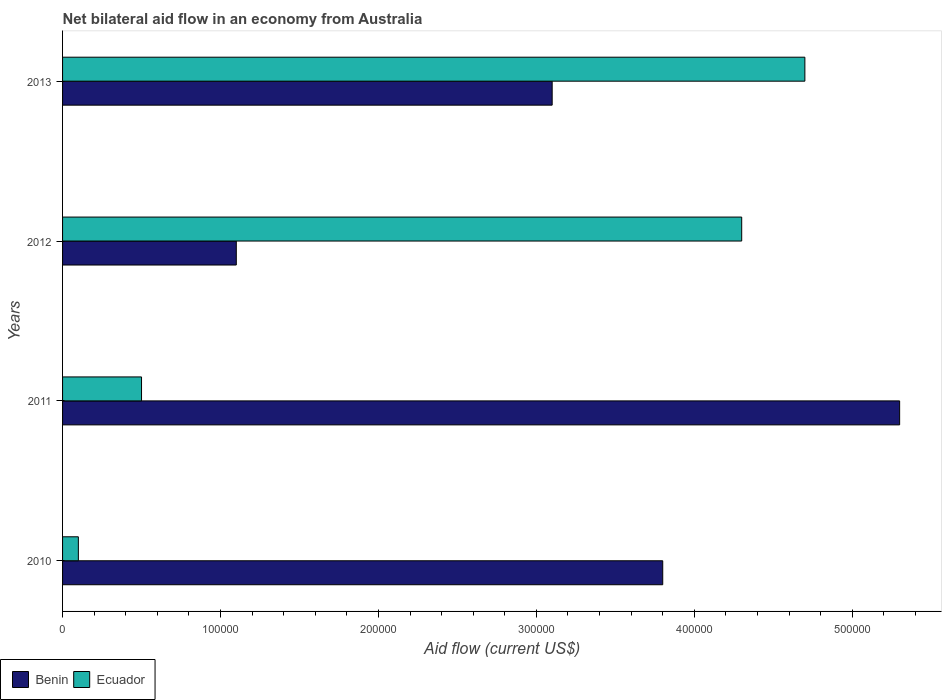How many different coloured bars are there?
Your answer should be very brief. 2. How many groups of bars are there?
Offer a terse response. 4. Are the number of bars per tick equal to the number of legend labels?
Provide a succinct answer. Yes. Are the number of bars on each tick of the Y-axis equal?
Your response must be concise. Yes. What is the label of the 1st group of bars from the top?
Offer a very short reply. 2013. In how many cases, is the number of bars for a given year not equal to the number of legend labels?
Give a very brief answer. 0. What is the net bilateral aid flow in Ecuador in 2012?
Offer a very short reply. 4.30e+05. Across all years, what is the maximum net bilateral aid flow in Benin?
Offer a terse response. 5.30e+05. Across all years, what is the minimum net bilateral aid flow in Benin?
Ensure brevity in your answer.  1.10e+05. In which year was the net bilateral aid flow in Benin maximum?
Ensure brevity in your answer.  2011. In which year was the net bilateral aid flow in Ecuador minimum?
Provide a short and direct response. 2010. What is the total net bilateral aid flow in Ecuador in the graph?
Provide a short and direct response. 9.60e+05. What is the difference between the net bilateral aid flow in Ecuador in 2010 and that in 2011?
Ensure brevity in your answer.  -4.00e+04. What is the ratio of the net bilateral aid flow in Ecuador in 2010 to that in 2012?
Provide a succinct answer. 0.02. In how many years, is the net bilateral aid flow in Benin greater than the average net bilateral aid flow in Benin taken over all years?
Provide a succinct answer. 2. What does the 2nd bar from the top in 2011 represents?
Ensure brevity in your answer.  Benin. What does the 1st bar from the bottom in 2012 represents?
Ensure brevity in your answer.  Benin. How many bars are there?
Your answer should be very brief. 8. Are all the bars in the graph horizontal?
Provide a succinct answer. Yes. What is the difference between two consecutive major ticks on the X-axis?
Offer a terse response. 1.00e+05. Where does the legend appear in the graph?
Make the answer very short. Bottom left. How many legend labels are there?
Your answer should be compact. 2. How are the legend labels stacked?
Provide a succinct answer. Horizontal. What is the title of the graph?
Your answer should be very brief. Net bilateral aid flow in an economy from Australia. Does "Spain" appear as one of the legend labels in the graph?
Ensure brevity in your answer.  No. What is the label or title of the Y-axis?
Your response must be concise. Years. What is the Aid flow (current US$) of Benin in 2010?
Keep it short and to the point. 3.80e+05. What is the Aid flow (current US$) in Ecuador in 2010?
Provide a succinct answer. 10000. What is the Aid flow (current US$) in Benin in 2011?
Ensure brevity in your answer.  5.30e+05. What is the Aid flow (current US$) of Ecuador in 2011?
Offer a very short reply. 5.00e+04. What is the Aid flow (current US$) in Benin in 2012?
Offer a very short reply. 1.10e+05. What is the Aid flow (current US$) of Ecuador in 2012?
Offer a terse response. 4.30e+05. Across all years, what is the maximum Aid flow (current US$) of Benin?
Make the answer very short. 5.30e+05. Across all years, what is the maximum Aid flow (current US$) of Ecuador?
Ensure brevity in your answer.  4.70e+05. Across all years, what is the minimum Aid flow (current US$) of Ecuador?
Your answer should be very brief. 10000. What is the total Aid flow (current US$) of Benin in the graph?
Give a very brief answer. 1.33e+06. What is the total Aid flow (current US$) in Ecuador in the graph?
Provide a succinct answer. 9.60e+05. What is the difference between the Aid flow (current US$) of Benin in 2010 and that in 2011?
Your answer should be very brief. -1.50e+05. What is the difference between the Aid flow (current US$) in Ecuador in 2010 and that in 2011?
Provide a succinct answer. -4.00e+04. What is the difference between the Aid flow (current US$) in Ecuador in 2010 and that in 2012?
Your answer should be very brief. -4.20e+05. What is the difference between the Aid flow (current US$) of Benin in 2010 and that in 2013?
Ensure brevity in your answer.  7.00e+04. What is the difference between the Aid flow (current US$) in Ecuador in 2010 and that in 2013?
Offer a terse response. -4.60e+05. What is the difference between the Aid flow (current US$) in Benin in 2011 and that in 2012?
Ensure brevity in your answer.  4.20e+05. What is the difference between the Aid flow (current US$) in Ecuador in 2011 and that in 2012?
Provide a succinct answer. -3.80e+05. What is the difference between the Aid flow (current US$) of Ecuador in 2011 and that in 2013?
Give a very brief answer. -4.20e+05. What is the difference between the Aid flow (current US$) in Benin in 2012 and that in 2013?
Ensure brevity in your answer.  -2.00e+05. What is the difference between the Aid flow (current US$) of Ecuador in 2012 and that in 2013?
Provide a succinct answer. -4.00e+04. What is the difference between the Aid flow (current US$) of Benin in 2010 and the Aid flow (current US$) of Ecuador in 2011?
Your answer should be very brief. 3.30e+05. What is the difference between the Aid flow (current US$) of Benin in 2010 and the Aid flow (current US$) of Ecuador in 2013?
Make the answer very short. -9.00e+04. What is the difference between the Aid flow (current US$) in Benin in 2012 and the Aid flow (current US$) in Ecuador in 2013?
Make the answer very short. -3.60e+05. What is the average Aid flow (current US$) of Benin per year?
Provide a short and direct response. 3.32e+05. In the year 2012, what is the difference between the Aid flow (current US$) in Benin and Aid flow (current US$) in Ecuador?
Offer a terse response. -3.20e+05. What is the ratio of the Aid flow (current US$) of Benin in 2010 to that in 2011?
Ensure brevity in your answer.  0.72. What is the ratio of the Aid flow (current US$) in Ecuador in 2010 to that in 2011?
Provide a succinct answer. 0.2. What is the ratio of the Aid flow (current US$) of Benin in 2010 to that in 2012?
Keep it short and to the point. 3.45. What is the ratio of the Aid flow (current US$) of Ecuador in 2010 to that in 2012?
Offer a very short reply. 0.02. What is the ratio of the Aid flow (current US$) of Benin in 2010 to that in 2013?
Offer a very short reply. 1.23. What is the ratio of the Aid flow (current US$) in Ecuador in 2010 to that in 2013?
Your answer should be very brief. 0.02. What is the ratio of the Aid flow (current US$) in Benin in 2011 to that in 2012?
Make the answer very short. 4.82. What is the ratio of the Aid flow (current US$) in Ecuador in 2011 to that in 2012?
Provide a short and direct response. 0.12. What is the ratio of the Aid flow (current US$) of Benin in 2011 to that in 2013?
Offer a terse response. 1.71. What is the ratio of the Aid flow (current US$) of Ecuador in 2011 to that in 2013?
Your answer should be very brief. 0.11. What is the ratio of the Aid flow (current US$) of Benin in 2012 to that in 2013?
Keep it short and to the point. 0.35. What is the ratio of the Aid flow (current US$) of Ecuador in 2012 to that in 2013?
Offer a very short reply. 0.91. What is the difference between the highest and the second highest Aid flow (current US$) of Benin?
Ensure brevity in your answer.  1.50e+05. What is the difference between the highest and the second highest Aid flow (current US$) of Ecuador?
Make the answer very short. 4.00e+04. 